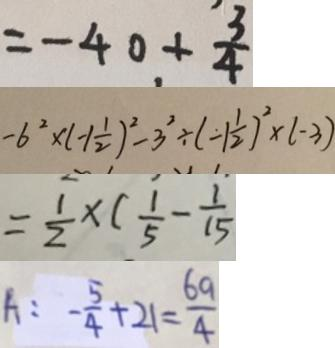Convert formula to latex. <formula><loc_0><loc_0><loc_500><loc_500>= - 4 0 + \frac { 3 } { 4 } 
 - 6 ^ { 2 } \times ( - 1 \frac { 1 } { 2 } ) ^ { 2 } - 3 ^ { 2 } \div ( - 1 \frac { 1 } { 2 } ) ^ { 2 } \times ( - 3 ) 
 = \frac { 1 } { 2 } \times ( \frac { 1 } { 5 } - \frac { 1 } { 1 5 } ) 
 A : - \frac { 5 } { 4 } + 2 1 = \frac { 6 9 } { 4 }</formula> 